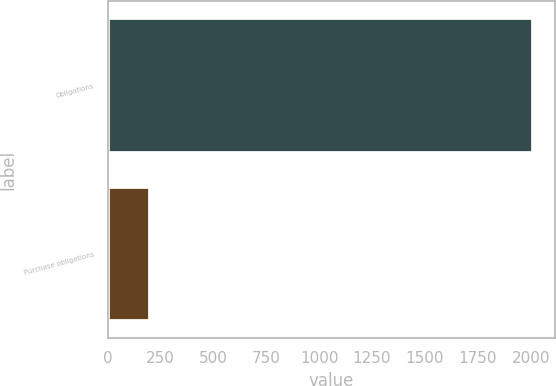<chart> <loc_0><loc_0><loc_500><loc_500><bar_chart><fcel>Obligations<fcel>Purchase obligations<nl><fcel>2013<fcel>201.7<nl></chart> 